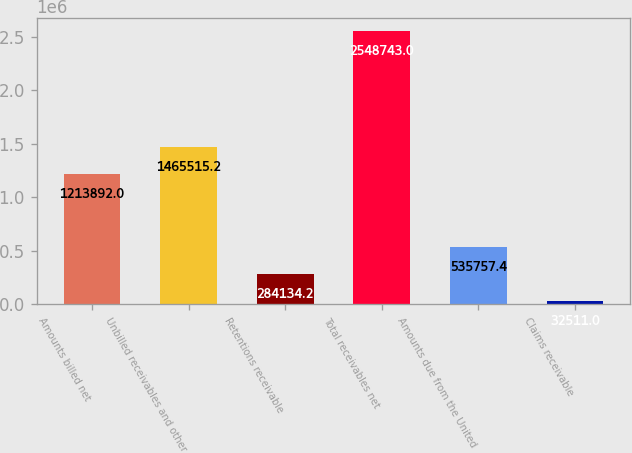Convert chart to OTSL. <chart><loc_0><loc_0><loc_500><loc_500><bar_chart><fcel>Amounts billed net<fcel>Unbilled receivables and other<fcel>Retentions receivable<fcel>Total receivables net<fcel>Amounts due from the United<fcel>Claims receivable<nl><fcel>1.21389e+06<fcel>1.46552e+06<fcel>284134<fcel>2.54874e+06<fcel>535757<fcel>32511<nl></chart> 